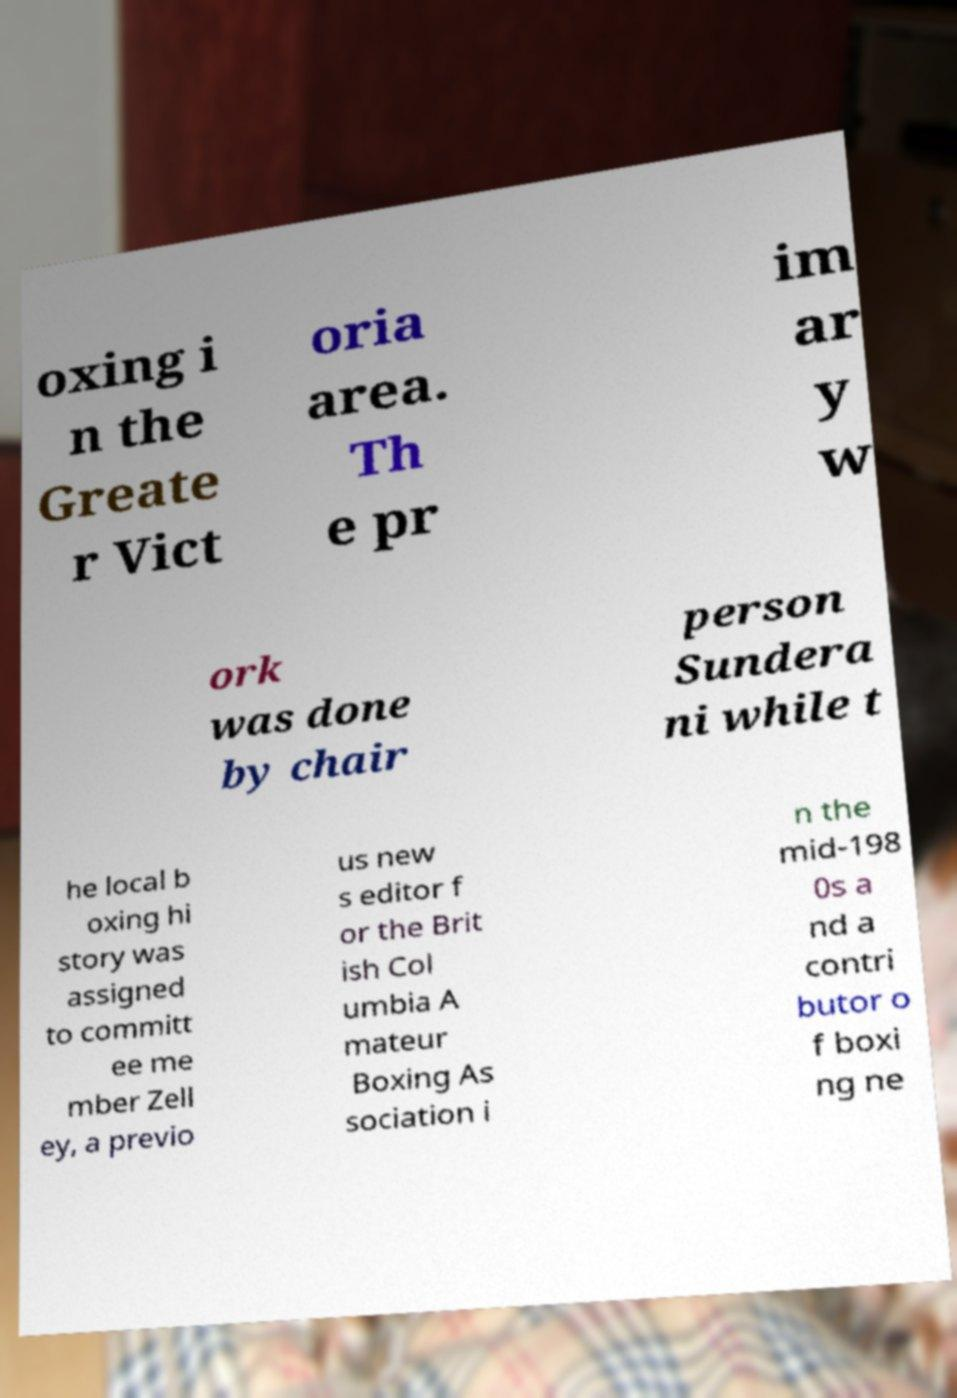Could you extract and type out the text from this image? oxing i n the Greate r Vict oria area. Th e pr im ar y w ork was done by chair person Sundera ni while t he local b oxing hi story was assigned to committ ee me mber Zell ey, a previo us new s editor f or the Brit ish Col umbia A mateur Boxing As sociation i n the mid-198 0s a nd a contri butor o f boxi ng ne 